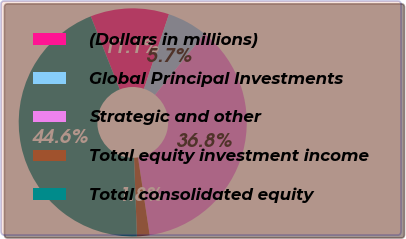Convert chart. <chart><loc_0><loc_0><loc_500><loc_500><pie_chart><fcel>(Dollars in millions)<fcel>Global Principal Investments<fcel>Strategic and other<fcel>Total equity investment income<fcel>Total consolidated equity<nl><fcel>11.14%<fcel>5.69%<fcel>36.8%<fcel>1.79%<fcel>44.59%<nl></chart> 